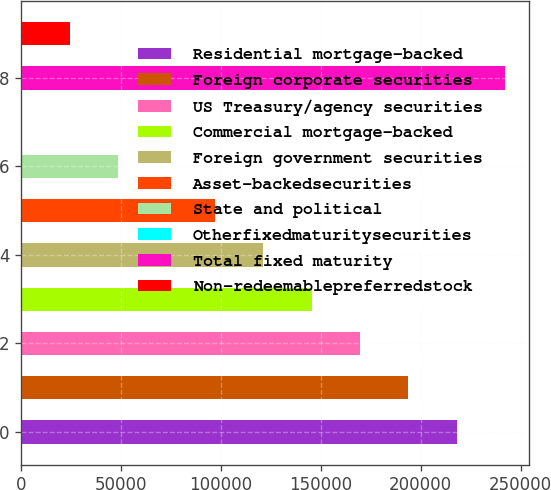Convert chart. <chart><loc_0><loc_0><loc_500><loc_500><bar_chart><fcel>Residential mortgage-backed<fcel>Foreign corporate securities<fcel>US Treasury/agency securities<fcel>Commercial mortgage-backed<fcel>Foreign government securities<fcel>Asset-backedsecurities<fcel>State and political<fcel>Otherfixedmaturitysecurities<fcel>Total fixed maturity<fcel>Non-redeemablepreferredstock<nl><fcel>218050<fcel>193857<fcel>169665<fcel>145472<fcel>121280<fcel>97087.6<fcel>48702.8<fcel>318<fcel>242242<fcel>24510.4<nl></chart> 